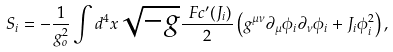<formula> <loc_0><loc_0><loc_500><loc_500>S _ { i } = - \frac { 1 } { g _ { o } ^ { 2 } } \int d ^ { 4 } x \sqrt { - g } \frac { \ F c ^ { \prime } ( J _ { i } ) } { 2 } \left ( g ^ { \mu \nu } \partial _ { \mu } \phi _ { i } \partial _ { \nu } \phi _ { i } + J _ { i } \phi _ { i } ^ { 2 } \right ) ,</formula> 